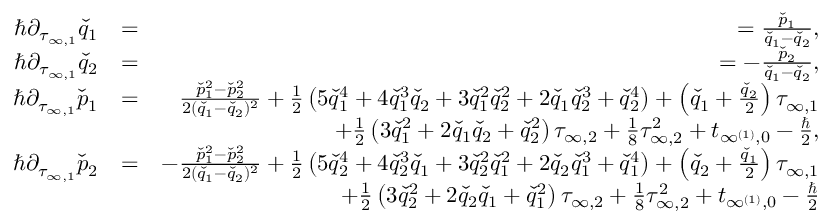<formula> <loc_0><loc_0><loc_500><loc_500>\begin{array} { r l r } { \hbar { \partial } _ { \tau _ { \infty , 1 } } \check { q } _ { 1 } } & { = } & { = \frac { \check { p } _ { 1 } } { \check { q } _ { 1 } - \check { q } _ { 2 } } , } \\ { \hbar { \partial } _ { \tau _ { \infty , 1 } } \check { q } _ { 2 } } & { = } & { = - \frac { \check { p } _ { 2 } } { \check { q } _ { 1 } - \check { q } _ { 2 } } , } \\ { \hbar { \partial } _ { \tau _ { \infty , 1 } } \check { p } _ { 1 } } & { = } & { \frac { \check { p } _ { 1 } ^ { 2 } - \check { p } _ { 2 } ^ { 2 } } { 2 ( \check { q } _ { 1 } - \check { q } _ { 2 } ) ^ { 2 } } + \frac { 1 } { 2 } \left ( 5 \check { q } _ { 1 } ^ { 4 } + 4 \check { q } _ { 1 } ^ { 3 } \check { q } _ { 2 } + 3 \check { q } _ { 1 } ^ { 2 } \check { q } _ { 2 } ^ { 2 } + 2 \check { q } _ { 1 } \check { q } _ { 2 } ^ { 3 } + \check { q } _ { 2 } ^ { 4 } \right ) + \left ( \check { q } _ { 1 } + \frac { \check { q } _ { 2 } } { 2 } \right ) \tau _ { \infty , 1 } } \\ & { + \frac { 1 } { 2 } \left ( 3 \check { q } _ { 1 } ^ { 2 } + 2 \check { q } _ { 1 } \check { q } _ { 2 } + \check { q } _ { 2 } ^ { 2 } \right ) \tau _ { \infty , 2 } + \frac { 1 } { 8 } \tau _ { \infty , 2 } ^ { 2 } + t _ { \infty ^ { ( 1 ) } , 0 } - \frac { } { 2 } , } \\ { \hbar { \partial } _ { \tau _ { \infty , 1 } } \check { p } _ { 2 } } & { = } & { - \frac { \check { p } _ { 1 } ^ { 2 } - \check { p } _ { 2 } ^ { 2 } } { 2 ( \check { q } _ { 1 } - \check { q } _ { 2 } ) ^ { 2 } } + \frac { 1 } { 2 } \left ( 5 \check { q } _ { 2 } ^ { 4 } + 4 \check { q } _ { 2 } ^ { 3 } \check { q } _ { 1 } + 3 \check { q } _ { 2 } ^ { 2 } \check { q } _ { 1 } ^ { 2 } + 2 \check { q } _ { 2 } \check { q } _ { 1 } ^ { 3 } + \check { q } _ { 1 } ^ { 4 } \right ) + \left ( \check { q } _ { 2 } + \frac { \check { q } _ { 1 } } { 2 } \right ) \tau _ { \infty , 1 } } \\ & { + \frac { 1 } { 2 } \left ( 3 \check { q } _ { 2 } ^ { 2 } + 2 \check { q } _ { 2 } \check { q } _ { 1 } + \check { q } _ { 1 } ^ { 2 } \right ) \tau _ { \infty , 2 } + \frac { 1 } { 8 } \tau _ { \infty , 2 } ^ { 2 } + t _ { \infty ^ { ( 1 ) } , 0 } - \frac { } { 2 } } \end{array}</formula> 